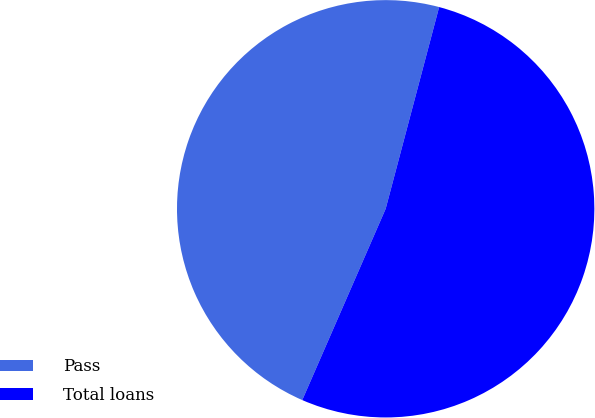Convert chart. <chart><loc_0><loc_0><loc_500><loc_500><pie_chart><fcel>Pass<fcel>Total loans<nl><fcel>47.58%<fcel>52.42%<nl></chart> 